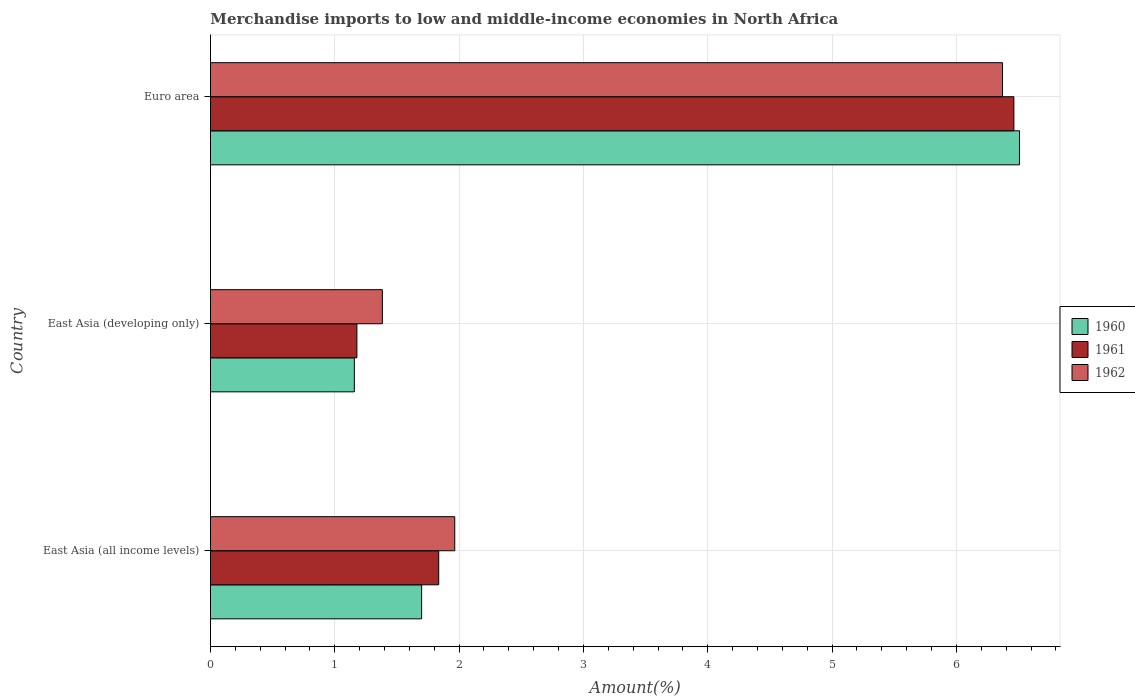How many groups of bars are there?
Your response must be concise. 3. Are the number of bars per tick equal to the number of legend labels?
Make the answer very short. Yes. Are the number of bars on each tick of the Y-axis equal?
Give a very brief answer. Yes. How many bars are there on the 2nd tick from the bottom?
Provide a short and direct response. 3. What is the percentage of amount earned from merchandise imports in 1960 in East Asia (all income levels)?
Provide a succinct answer. 1.7. Across all countries, what is the maximum percentage of amount earned from merchandise imports in 1960?
Provide a short and direct response. 6.51. Across all countries, what is the minimum percentage of amount earned from merchandise imports in 1961?
Ensure brevity in your answer.  1.18. In which country was the percentage of amount earned from merchandise imports in 1960 maximum?
Your answer should be compact. Euro area. In which country was the percentage of amount earned from merchandise imports in 1960 minimum?
Keep it short and to the point. East Asia (developing only). What is the total percentage of amount earned from merchandise imports in 1961 in the graph?
Offer a very short reply. 9.48. What is the difference between the percentage of amount earned from merchandise imports in 1962 in East Asia (developing only) and that in Euro area?
Your answer should be very brief. -4.99. What is the difference between the percentage of amount earned from merchandise imports in 1962 in Euro area and the percentage of amount earned from merchandise imports in 1961 in East Asia (developing only)?
Provide a short and direct response. 5.19. What is the average percentage of amount earned from merchandise imports in 1962 per country?
Provide a succinct answer. 3.24. What is the difference between the percentage of amount earned from merchandise imports in 1960 and percentage of amount earned from merchandise imports in 1961 in Euro area?
Provide a short and direct response. 0.05. In how many countries, is the percentage of amount earned from merchandise imports in 1962 greater than 3.8 %?
Ensure brevity in your answer.  1. What is the ratio of the percentage of amount earned from merchandise imports in 1961 in East Asia (developing only) to that in Euro area?
Ensure brevity in your answer.  0.18. What is the difference between the highest and the second highest percentage of amount earned from merchandise imports in 1961?
Ensure brevity in your answer.  4.63. What is the difference between the highest and the lowest percentage of amount earned from merchandise imports in 1960?
Make the answer very short. 5.35. Is the sum of the percentage of amount earned from merchandise imports in 1960 in East Asia (developing only) and Euro area greater than the maximum percentage of amount earned from merchandise imports in 1961 across all countries?
Offer a terse response. Yes. What does the 1st bar from the top in Euro area represents?
Provide a short and direct response. 1962. What does the 3rd bar from the bottom in East Asia (developing only) represents?
Offer a terse response. 1962. Are all the bars in the graph horizontal?
Offer a very short reply. Yes. Does the graph contain any zero values?
Provide a succinct answer. No. How many legend labels are there?
Make the answer very short. 3. How are the legend labels stacked?
Your answer should be compact. Vertical. What is the title of the graph?
Offer a very short reply. Merchandise imports to low and middle-income economies in North Africa. What is the label or title of the X-axis?
Offer a very short reply. Amount(%). What is the Amount(%) of 1960 in East Asia (all income levels)?
Make the answer very short. 1.7. What is the Amount(%) in 1961 in East Asia (all income levels)?
Provide a succinct answer. 1.84. What is the Amount(%) of 1962 in East Asia (all income levels)?
Provide a succinct answer. 1.96. What is the Amount(%) in 1960 in East Asia (developing only)?
Your answer should be compact. 1.16. What is the Amount(%) of 1961 in East Asia (developing only)?
Your answer should be compact. 1.18. What is the Amount(%) in 1962 in East Asia (developing only)?
Your answer should be very brief. 1.38. What is the Amount(%) in 1960 in Euro area?
Provide a succinct answer. 6.51. What is the Amount(%) in 1961 in Euro area?
Ensure brevity in your answer.  6.46. What is the Amount(%) of 1962 in Euro area?
Ensure brevity in your answer.  6.37. Across all countries, what is the maximum Amount(%) of 1960?
Provide a short and direct response. 6.51. Across all countries, what is the maximum Amount(%) in 1961?
Your answer should be very brief. 6.46. Across all countries, what is the maximum Amount(%) of 1962?
Offer a terse response. 6.37. Across all countries, what is the minimum Amount(%) of 1960?
Make the answer very short. 1.16. Across all countries, what is the minimum Amount(%) in 1961?
Your response must be concise. 1.18. Across all countries, what is the minimum Amount(%) in 1962?
Provide a succinct answer. 1.38. What is the total Amount(%) in 1960 in the graph?
Make the answer very short. 9.36. What is the total Amount(%) in 1961 in the graph?
Your answer should be very brief. 9.48. What is the total Amount(%) in 1962 in the graph?
Offer a terse response. 9.72. What is the difference between the Amount(%) in 1960 in East Asia (all income levels) and that in East Asia (developing only)?
Provide a succinct answer. 0.54. What is the difference between the Amount(%) of 1961 in East Asia (all income levels) and that in East Asia (developing only)?
Make the answer very short. 0.66. What is the difference between the Amount(%) of 1962 in East Asia (all income levels) and that in East Asia (developing only)?
Keep it short and to the point. 0.58. What is the difference between the Amount(%) in 1960 in East Asia (all income levels) and that in Euro area?
Keep it short and to the point. -4.81. What is the difference between the Amount(%) of 1961 in East Asia (all income levels) and that in Euro area?
Provide a succinct answer. -4.63. What is the difference between the Amount(%) of 1962 in East Asia (all income levels) and that in Euro area?
Make the answer very short. -4.41. What is the difference between the Amount(%) of 1960 in East Asia (developing only) and that in Euro area?
Your answer should be very brief. -5.35. What is the difference between the Amount(%) in 1961 in East Asia (developing only) and that in Euro area?
Provide a succinct answer. -5.28. What is the difference between the Amount(%) of 1962 in East Asia (developing only) and that in Euro area?
Provide a succinct answer. -4.99. What is the difference between the Amount(%) in 1960 in East Asia (all income levels) and the Amount(%) in 1961 in East Asia (developing only)?
Your answer should be compact. 0.52. What is the difference between the Amount(%) of 1960 in East Asia (all income levels) and the Amount(%) of 1962 in East Asia (developing only)?
Keep it short and to the point. 0.32. What is the difference between the Amount(%) in 1961 in East Asia (all income levels) and the Amount(%) in 1962 in East Asia (developing only)?
Keep it short and to the point. 0.45. What is the difference between the Amount(%) of 1960 in East Asia (all income levels) and the Amount(%) of 1961 in Euro area?
Provide a succinct answer. -4.76. What is the difference between the Amount(%) in 1960 in East Asia (all income levels) and the Amount(%) in 1962 in Euro area?
Your response must be concise. -4.67. What is the difference between the Amount(%) of 1961 in East Asia (all income levels) and the Amount(%) of 1962 in Euro area?
Keep it short and to the point. -4.53. What is the difference between the Amount(%) of 1960 in East Asia (developing only) and the Amount(%) of 1961 in Euro area?
Keep it short and to the point. -5.31. What is the difference between the Amount(%) of 1960 in East Asia (developing only) and the Amount(%) of 1962 in Euro area?
Offer a very short reply. -5.21. What is the difference between the Amount(%) of 1961 in East Asia (developing only) and the Amount(%) of 1962 in Euro area?
Your answer should be very brief. -5.19. What is the average Amount(%) in 1960 per country?
Keep it short and to the point. 3.12. What is the average Amount(%) in 1961 per country?
Your response must be concise. 3.16. What is the average Amount(%) of 1962 per country?
Ensure brevity in your answer.  3.24. What is the difference between the Amount(%) of 1960 and Amount(%) of 1961 in East Asia (all income levels)?
Your answer should be very brief. -0.14. What is the difference between the Amount(%) of 1960 and Amount(%) of 1962 in East Asia (all income levels)?
Your answer should be very brief. -0.27. What is the difference between the Amount(%) in 1961 and Amount(%) in 1962 in East Asia (all income levels)?
Provide a succinct answer. -0.13. What is the difference between the Amount(%) of 1960 and Amount(%) of 1961 in East Asia (developing only)?
Provide a short and direct response. -0.02. What is the difference between the Amount(%) of 1960 and Amount(%) of 1962 in East Asia (developing only)?
Provide a short and direct response. -0.23. What is the difference between the Amount(%) of 1961 and Amount(%) of 1962 in East Asia (developing only)?
Ensure brevity in your answer.  -0.2. What is the difference between the Amount(%) of 1960 and Amount(%) of 1961 in Euro area?
Give a very brief answer. 0.05. What is the difference between the Amount(%) in 1960 and Amount(%) in 1962 in Euro area?
Offer a terse response. 0.14. What is the difference between the Amount(%) in 1961 and Amount(%) in 1962 in Euro area?
Provide a short and direct response. 0.09. What is the ratio of the Amount(%) in 1960 in East Asia (all income levels) to that in East Asia (developing only)?
Provide a succinct answer. 1.47. What is the ratio of the Amount(%) in 1961 in East Asia (all income levels) to that in East Asia (developing only)?
Make the answer very short. 1.56. What is the ratio of the Amount(%) of 1962 in East Asia (all income levels) to that in East Asia (developing only)?
Offer a very short reply. 1.42. What is the ratio of the Amount(%) in 1960 in East Asia (all income levels) to that in Euro area?
Provide a short and direct response. 0.26. What is the ratio of the Amount(%) in 1961 in East Asia (all income levels) to that in Euro area?
Ensure brevity in your answer.  0.28. What is the ratio of the Amount(%) of 1962 in East Asia (all income levels) to that in Euro area?
Offer a terse response. 0.31. What is the ratio of the Amount(%) in 1960 in East Asia (developing only) to that in Euro area?
Your answer should be compact. 0.18. What is the ratio of the Amount(%) in 1961 in East Asia (developing only) to that in Euro area?
Provide a succinct answer. 0.18. What is the ratio of the Amount(%) of 1962 in East Asia (developing only) to that in Euro area?
Keep it short and to the point. 0.22. What is the difference between the highest and the second highest Amount(%) of 1960?
Your response must be concise. 4.81. What is the difference between the highest and the second highest Amount(%) in 1961?
Your response must be concise. 4.63. What is the difference between the highest and the second highest Amount(%) of 1962?
Offer a very short reply. 4.41. What is the difference between the highest and the lowest Amount(%) of 1960?
Offer a terse response. 5.35. What is the difference between the highest and the lowest Amount(%) in 1961?
Your response must be concise. 5.28. What is the difference between the highest and the lowest Amount(%) of 1962?
Give a very brief answer. 4.99. 